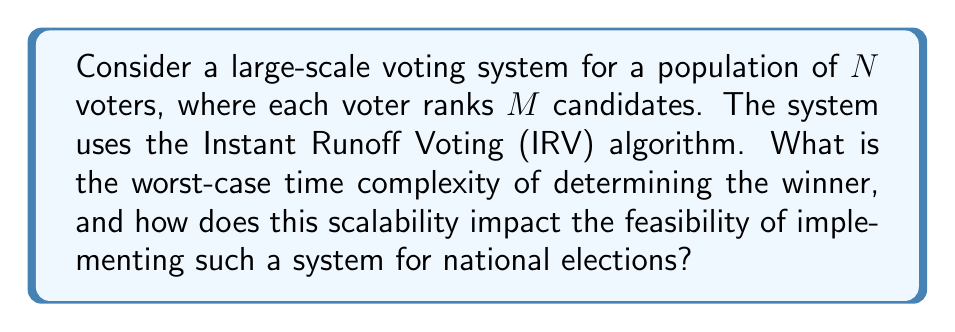Provide a solution to this math problem. To analyze the scalability of the Instant Runoff Voting (IRV) algorithm for large populations, we need to consider its time complexity:

1. Input size:
   - $N$ voters
   - $M$ candidates

2. IRV Algorithm steps:
   a) Count first-choice votes for each candidate
   b) Check if any candidate has a majority (>50%)
   c) If no majority, eliminate the candidate with the fewest votes
   d) Redistribute votes from the eliminated candidate
   e) Repeat steps b-d until a winner is determined

3. Worst-case scenario:
   - No candidate achieves a majority until the final round
   - We need to eliminate $M-1$ candidates

4. Time complexity analysis:
   a) Initial count: $O(N)$
   b) Checking for majority: $O(M)$
   c) Finding candidate with fewest votes: $O(M)$
   d) Redistributing votes: $O(N)$ (worst case, all votes need redistribution)
   e) Repeat steps b-d for $M-1$ rounds

5. Total worst-case time complexity:
   $$O(N + (M-1)(M + M + N)) = O(N + (M-1)(2M + N)) = O(NM + M^2)$$

6. Scalability implications:
   - As $N$ (number of voters) increases, the time complexity grows linearly
   - As $M$ (number of candidates) increases, the time complexity grows quadratically
   - For national elections with millions of voters and multiple candidates, this algorithm may become computationally expensive

7. Feasibility for national elections:
   - The quadratic growth in terms of candidates is less concerning, as the number of candidates is typically much smaller than the number of voters
   - The linear growth in terms of voters is more significant for large-scale elections
   - Parallelization and distributed computing could potentially mitigate some scalability issues
   - However, the need for multiple rounds of vote redistribution may introduce latency in reporting results

8. Comparative economic systems perspective:
   - The scalability of voting algorithms directly impacts the efficiency and cost of implementing different voting systems
   - More complex voting systems (like IRV) may offer benefits in terms of voter representation but come with higher computational costs
   - Policymakers must balance the trade-offs between voting system complexity, computational requirements, and the speed of obtaining results when designing electoral systems
Answer: The worst-case time complexity of the IRV algorithm for $N$ voters and $M$ candidates is $O(NM + M^2)$. This quadratic growth in terms of candidates and linear growth in terms of voters may pose significant scalability challenges for large-scale national elections, potentially impacting the feasibility of implementing such a system without substantial computational resources and optimizations. 